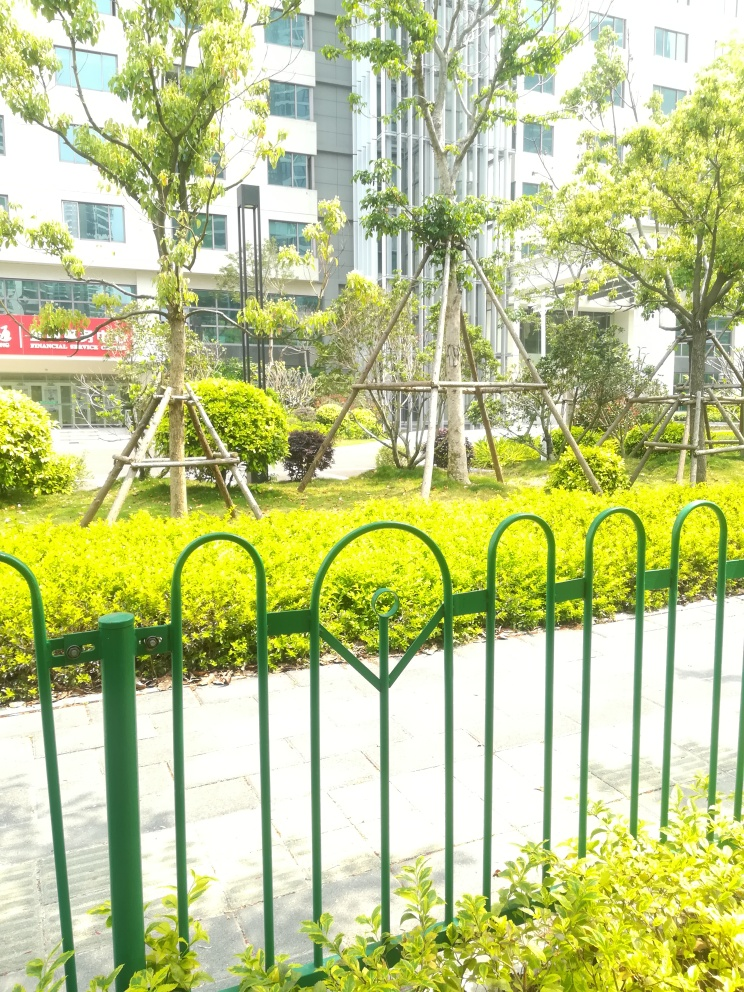The trees seem to be supported by structures. Can you tell me more about why this might be necessary? The young trees are supported by structures made of wooden stakes tied together and anchored to the ground. These supports are commonly used in landscaping to stabilize young trees until their root systems are fully developed and strong enough to withstand wind and the weight of their own canopy. It also helps to maintain the trees' vertical growth and prevent them from leaning or growing incorrectly. This care signifies a dedication to the long-term health and visual appeal of the urban landscape. 